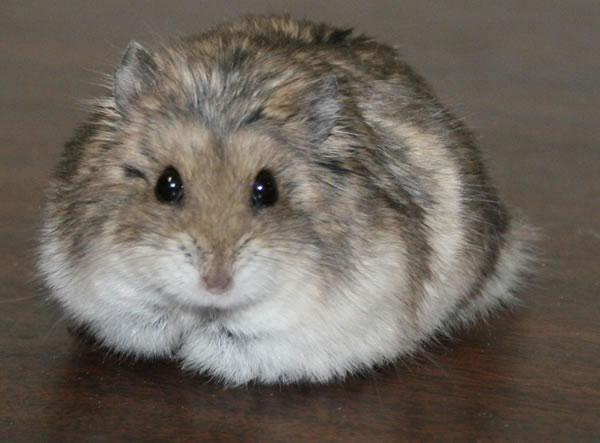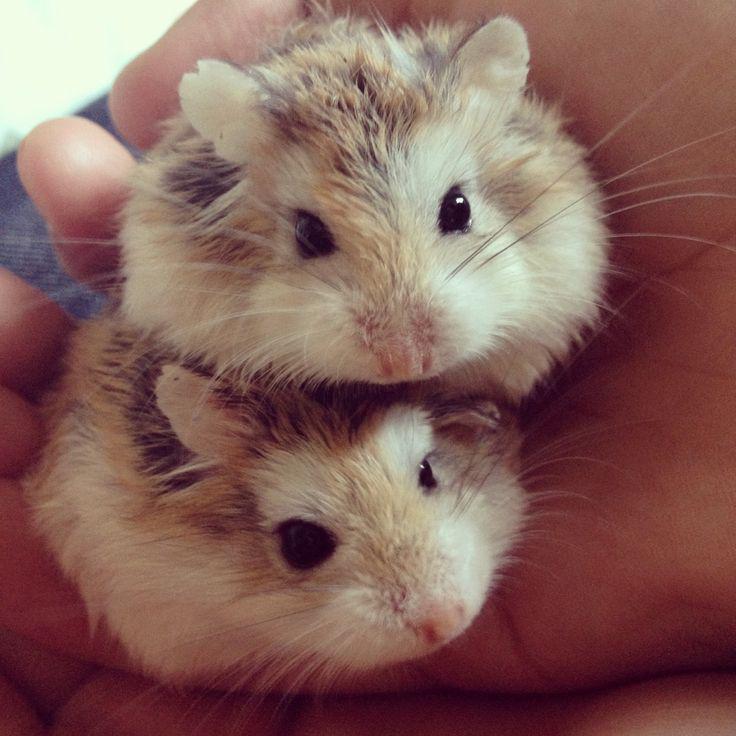The first image is the image on the left, the second image is the image on the right. Evaluate the accuracy of this statement regarding the images: "At least one hamster is sitting on wood shavings.". Is it true? Answer yes or no. No. The first image is the image on the left, the second image is the image on the right. Assess this claim about the two images: "The image pair contains one hamster in the left image and two hamsters in the right image.". Correct or not? Answer yes or no. Yes. 